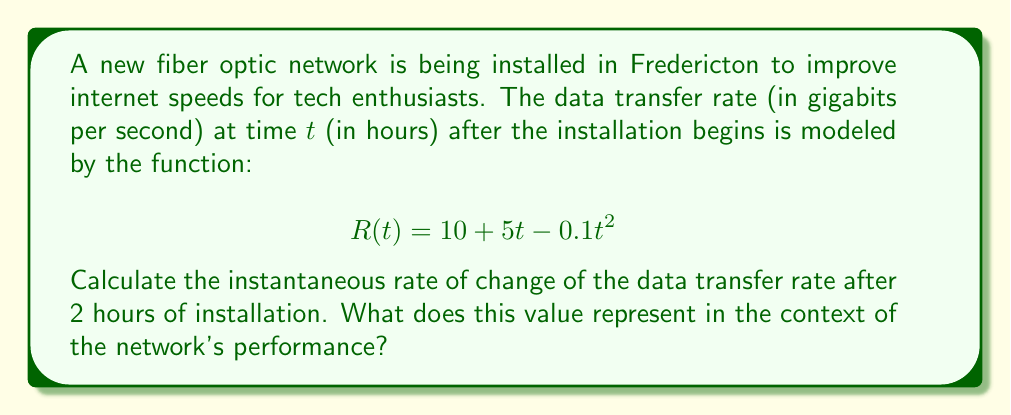Could you help me with this problem? To solve this problem, we need to use derivatives to find the instantaneous rate of change of the data transfer rate function.

1. First, let's find the derivative of the given function $R(t)$:
   
   $$R(t) = 10 + 5t - 0.1t^2$$
   $$R'(t) = 5 - 0.2t$$

   This derivative represents the rate of change of the data transfer rate at any given time $t$.

2. Now, we need to calculate the instantaneous rate of change after 2 hours. We can do this by evaluating $R'(t)$ at $t = 2$:

   $$R'(2) = 5 - 0.2(2)$$
   $$R'(2) = 5 - 0.4$$
   $$R'(2) = 4.6$$

3. Interpreting the result:
   The instantaneous rate of change of the data transfer rate after 2 hours is 4.6 Gbps/hour. This means that at the 2-hour mark, the data transfer rate is increasing at a rate of 4.6 gigabits per second every hour.

   In the context of the network's performance, this positive value indicates that the data transfer rate is still improving 2 hours into the installation. However, since the second derivative of $R(t)$ is negative (-0.2), the rate of improvement is slowing down over time.
Answer: The instantaneous rate of change of the data transfer rate after 2 hours of installation is 4.6 Gbps/hour. 